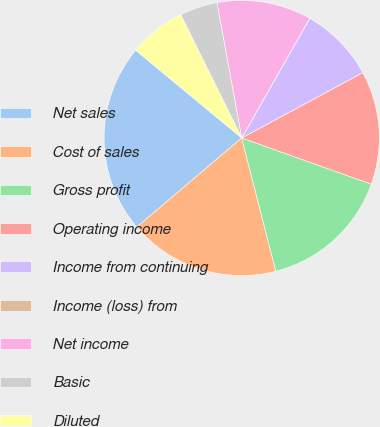<chart> <loc_0><loc_0><loc_500><loc_500><pie_chart><fcel>Net sales<fcel>Cost of sales<fcel>Gross profit<fcel>Operating income<fcel>Income from continuing<fcel>Income (loss) from<fcel>Net income<fcel>Basic<fcel>Diluted<nl><fcel>22.22%<fcel>17.78%<fcel>15.56%<fcel>13.33%<fcel>8.89%<fcel>0.0%<fcel>11.11%<fcel>4.44%<fcel>6.67%<nl></chart> 